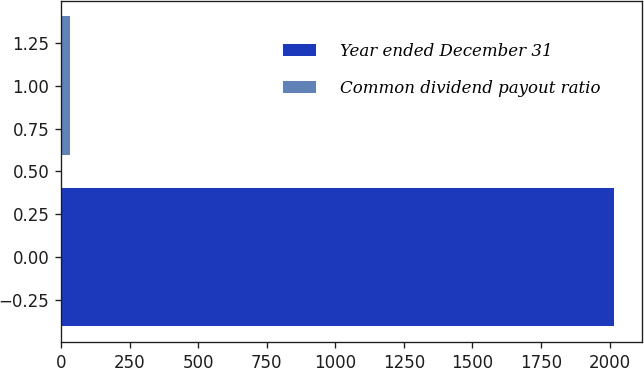Convert chart to OTSL. <chart><loc_0><loc_0><loc_500><loc_500><bar_chart><fcel>Year ended December 31<fcel>Common dividend payout ratio<nl><fcel>2017<fcel>33<nl></chart> 